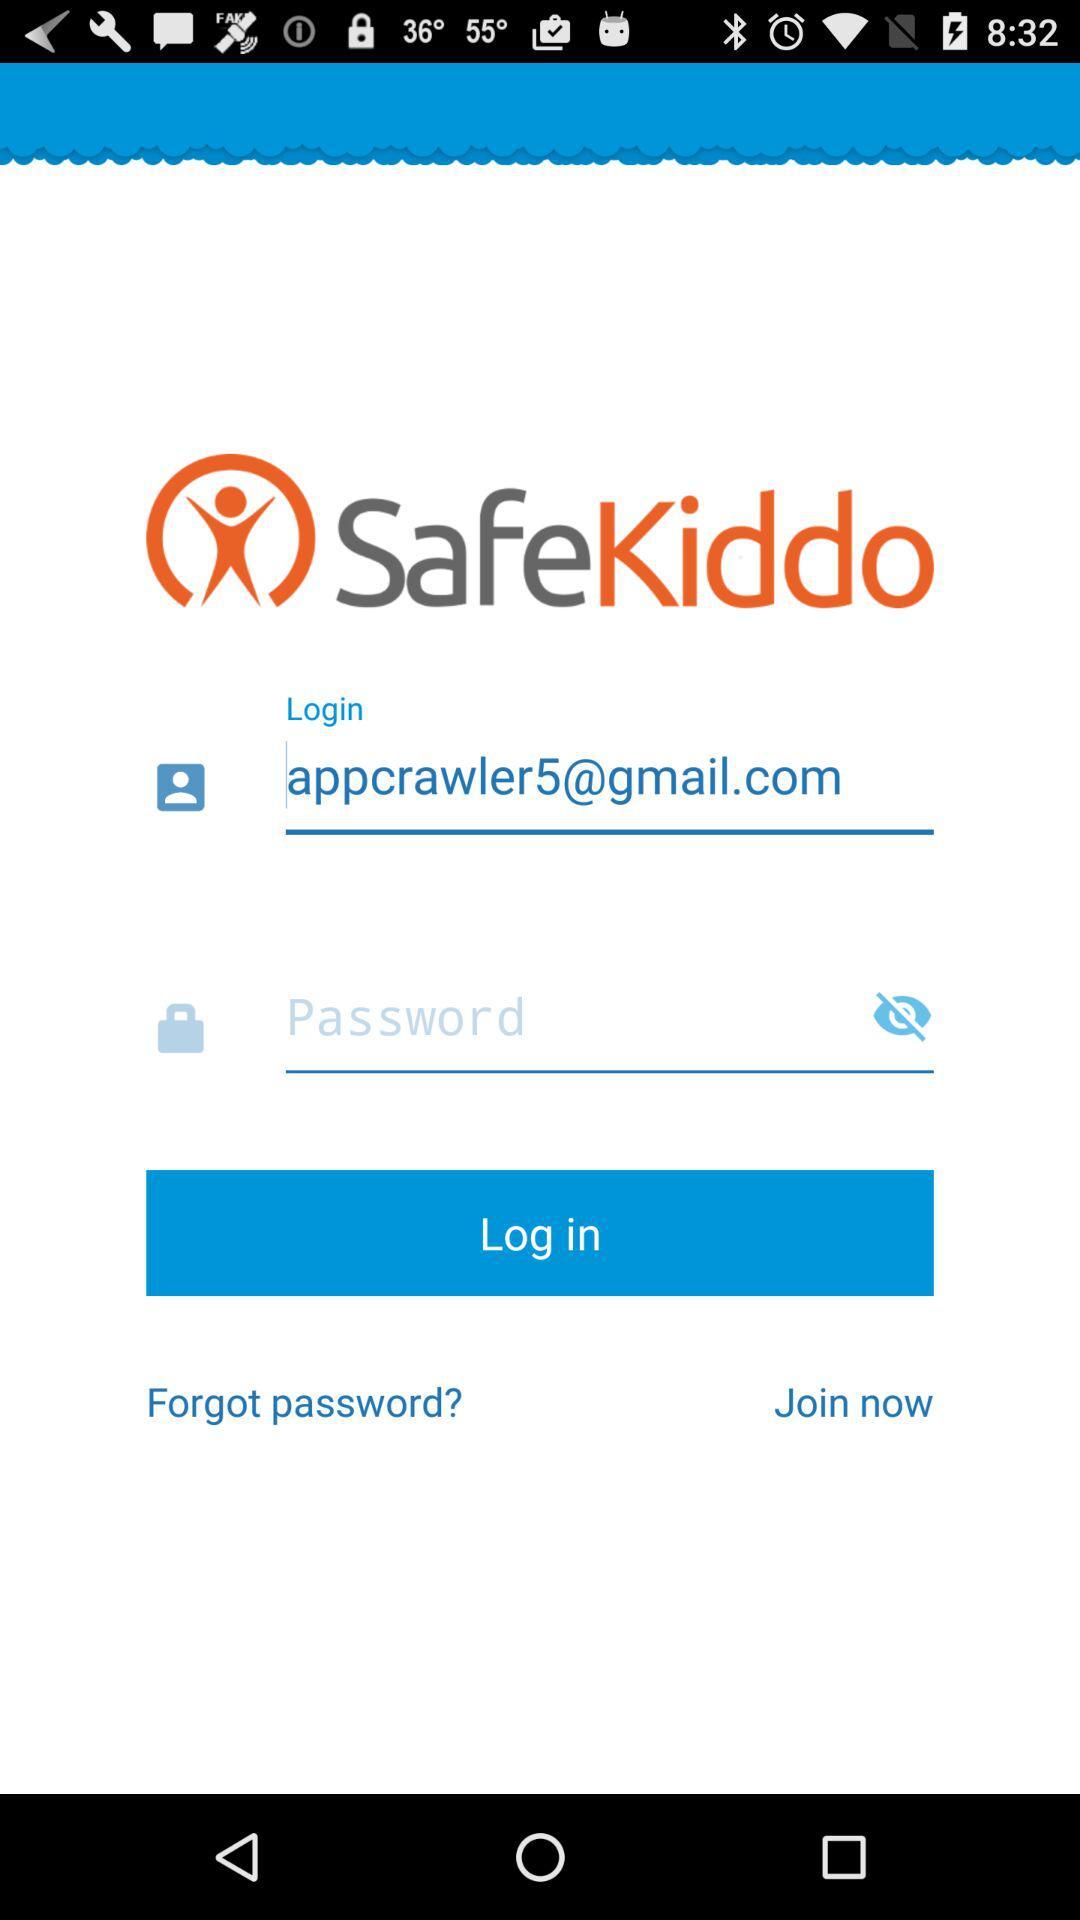What user ID is used to log in? The user ID that is used to log in is appcrawler5@gmail.com. 